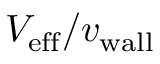<formula> <loc_0><loc_0><loc_500><loc_500>{ V _ { e f f } } / { v _ { w a l l } }</formula> 